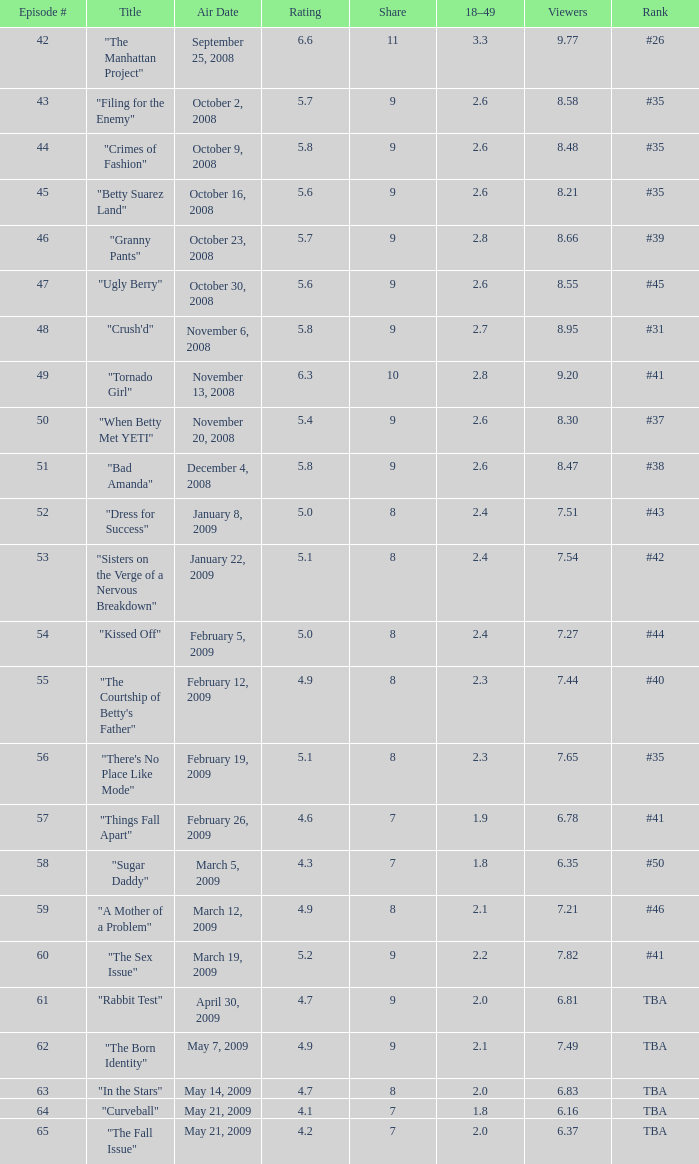54 viewers, and a rating not exceeding April 30, 2009, May 14, 2009, May 21, 2009. 